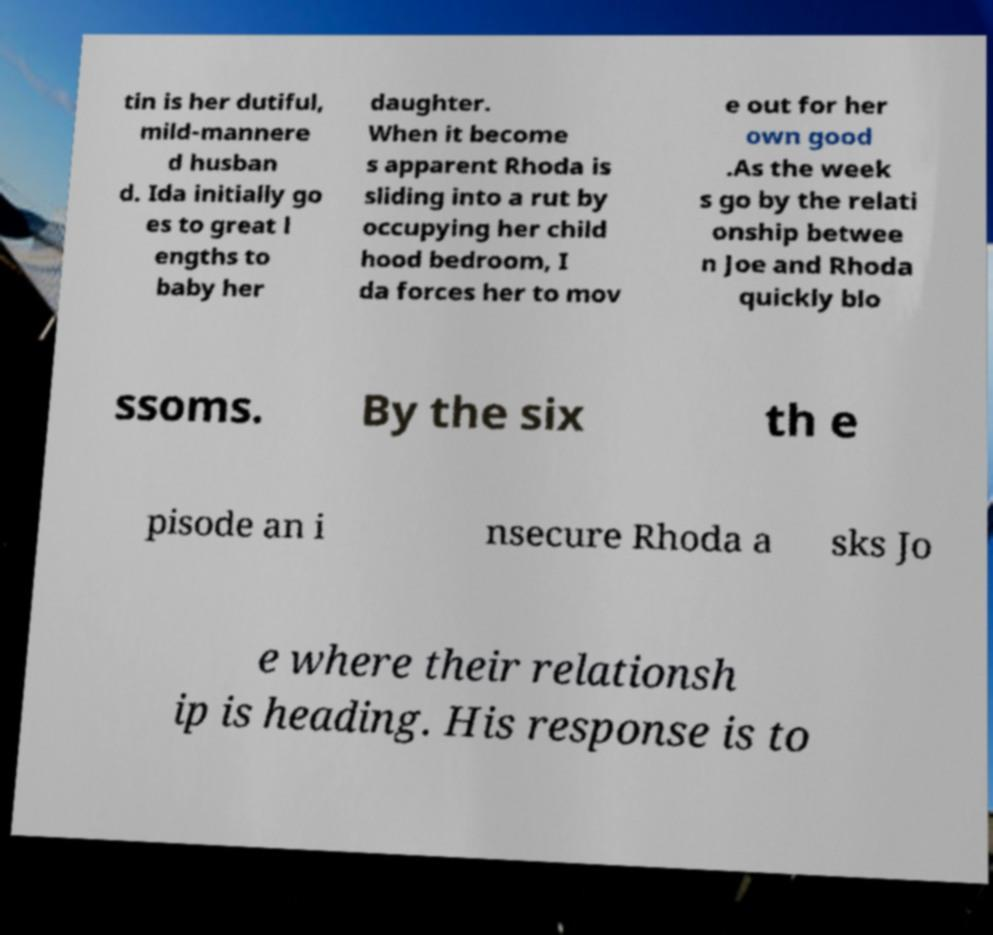Please read and relay the text visible in this image. What does it say? tin is her dutiful, mild-mannere d husban d. Ida initially go es to great l engths to baby her daughter. When it become s apparent Rhoda is sliding into a rut by occupying her child hood bedroom, I da forces her to mov e out for her own good .As the week s go by the relati onship betwee n Joe and Rhoda quickly blo ssoms. By the six th e pisode an i nsecure Rhoda a sks Jo e where their relationsh ip is heading. His response is to 